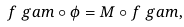<formula> <loc_0><loc_0><loc_500><loc_500>f _ { \ } g a m \circ \phi = M \circ f _ { \ } g a m ,</formula> 